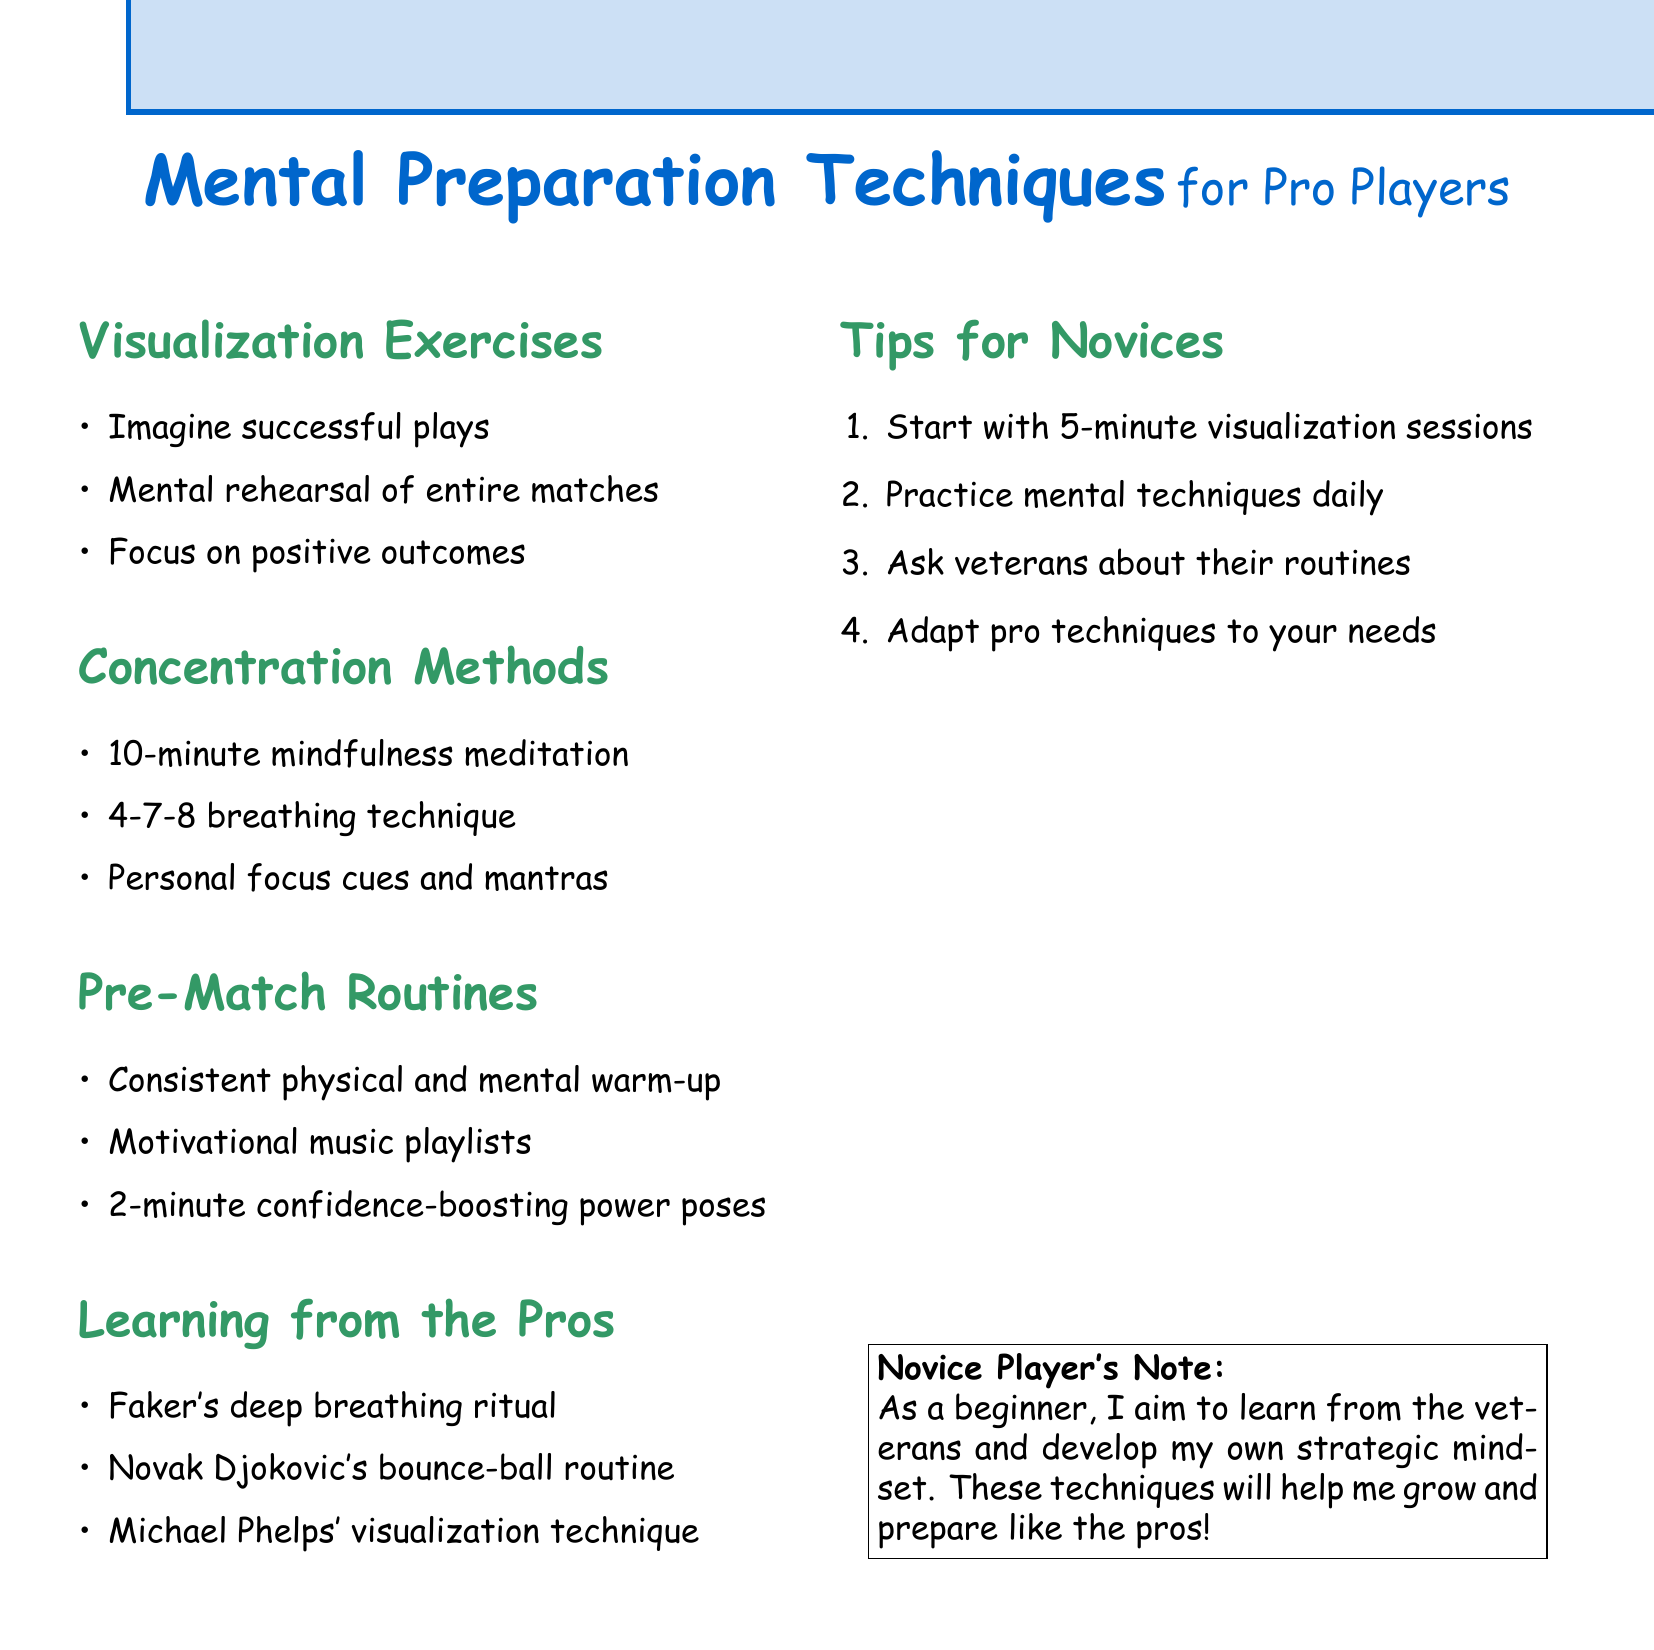What is the title of the document? The title of the document is specifically stated as the main heading.
Answer: Mental Preparation Techniques for Pro Players How many visualization exercises are listed? The document lists specific points under the Visualization Exercises section.
Answer: Three Name one concentration method mentioned. The concentration methods are detailed with specific techniques in the document.
Answer: Mindfulness meditation What is a suggested length for mindfulness meditation sessions? The document provides specific durations for the mindfulness sessions.
Answer: Ten minutes Which professional player's pre-game ritual involves deep breathing? The document highlights examples of professional players and their techniques in the Learning from the Pros section.
Answer: Faker What is one tip for novice players? The final section offers specific tips directed at beginners.
Answer: Start small Which technique is recommended for calming nerves? The document provides specific methods under the Concentration Methods section.
Answer: 4-7-8 breathing technique What is the purpose of using power poses before matches? The document explains various techniques along with their purposes, specifically about power poses.
Answer: Confidence-boosting How many points are listed under the Pre-Match Routines? The document categorizes points under various sections, including Pre-Match Routines.
Answer: Three 